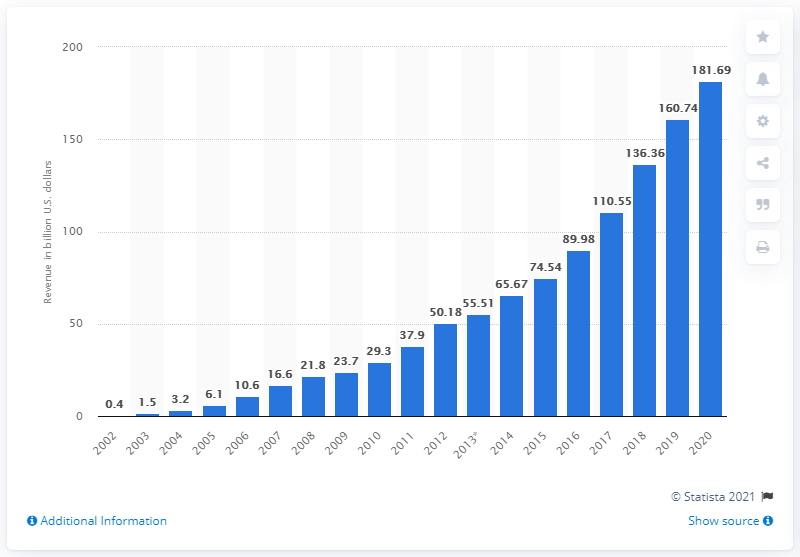Identify some key points in this picture. In the most recent fiscal year, Google's revenue was $181.69 billion. 